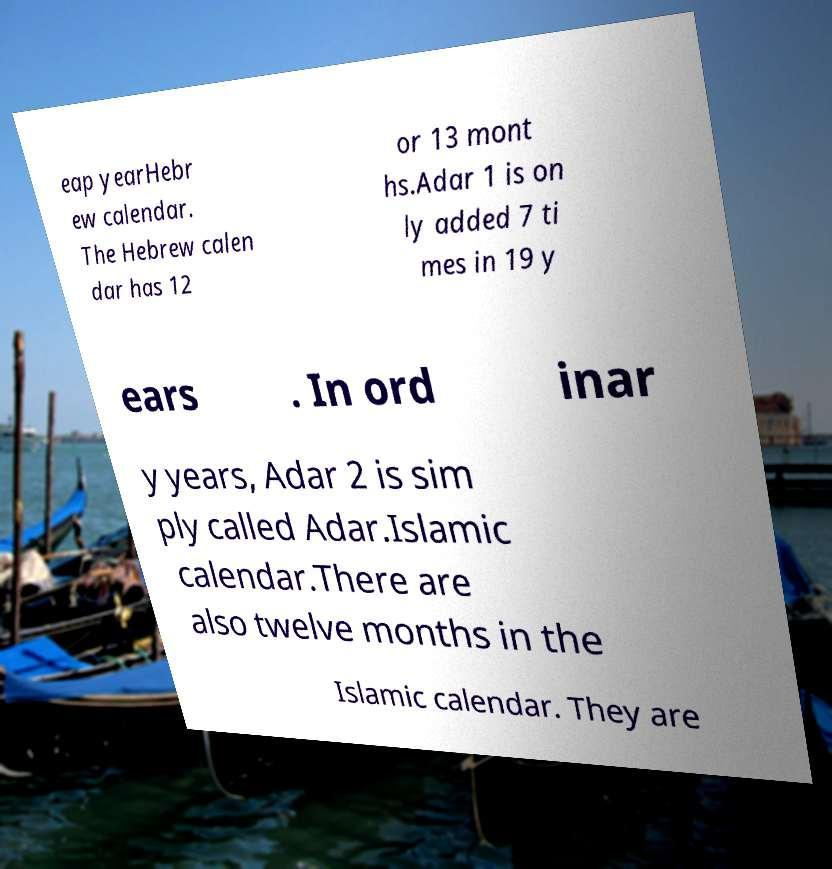Could you assist in decoding the text presented in this image and type it out clearly? eap yearHebr ew calendar. The Hebrew calen dar has 12 or 13 mont hs.Adar 1 is on ly added 7 ti mes in 19 y ears . In ord inar y years, Adar 2 is sim ply called Adar.Islamic calendar.There are also twelve months in the Islamic calendar. They are 